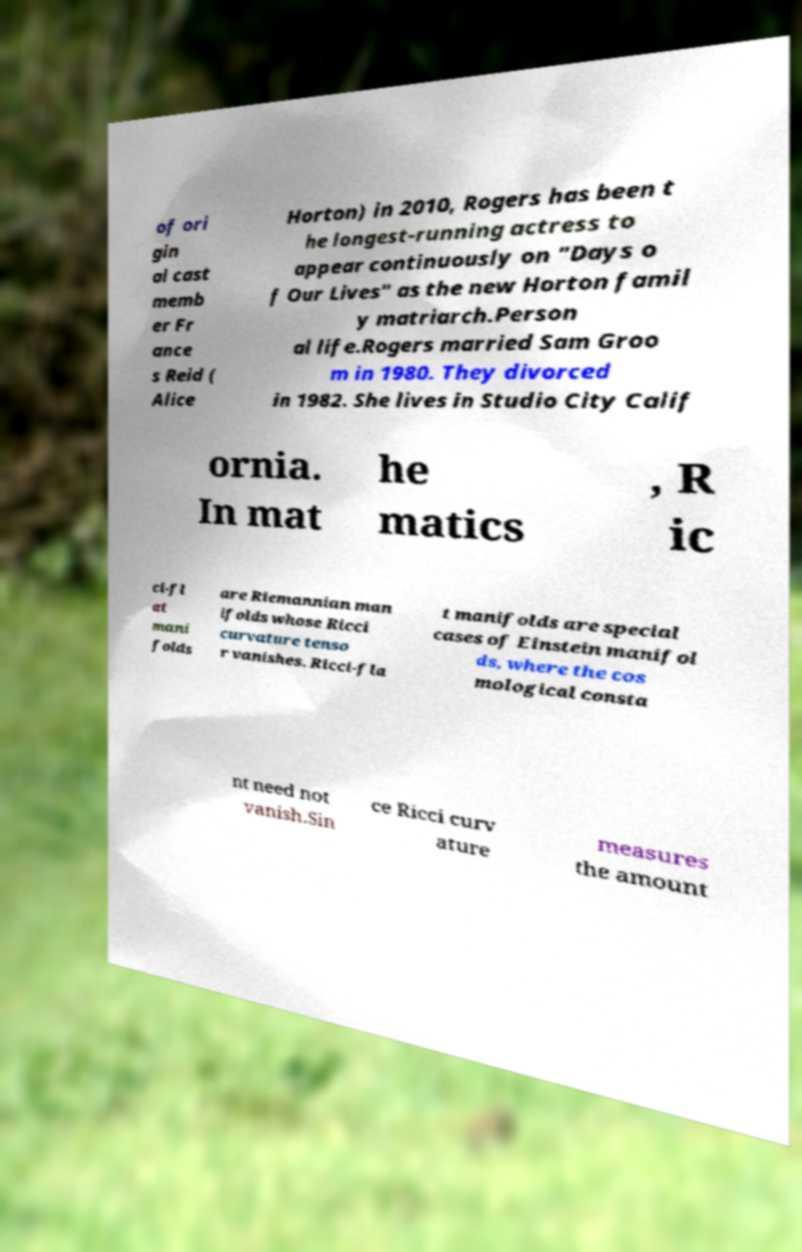For documentation purposes, I need the text within this image transcribed. Could you provide that? of ori gin al cast memb er Fr ance s Reid ( Alice Horton) in 2010, Rogers has been t he longest-running actress to appear continuously on "Days o f Our Lives" as the new Horton famil y matriarch.Person al life.Rogers married Sam Groo m in 1980. They divorced in 1982. She lives in Studio City Calif ornia. In mat he matics , R ic ci-fl at mani folds are Riemannian man ifolds whose Ricci curvature tenso r vanishes. Ricci-fla t manifolds are special cases of Einstein manifol ds, where the cos mological consta nt need not vanish.Sin ce Ricci curv ature measures the amount 